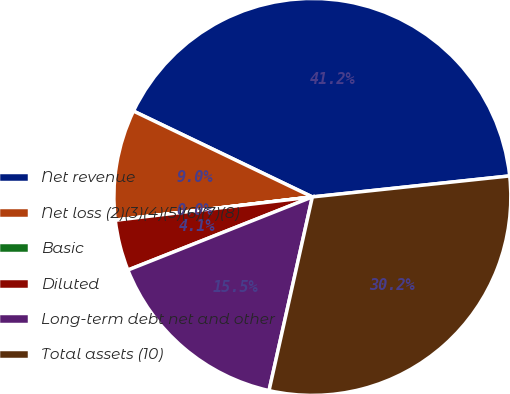Convert chart. <chart><loc_0><loc_0><loc_500><loc_500><pie_chart><fcel>Net revenue<fcel>Net loss (2)(3)(4)(5)(6)(7)(8)<fcel>Basic<fcel>Diluted<fcel>Long-term debt net and other<fcel>Total assets (10)<nl><fcel>41.19%<fcel>8.99%<fcel>0.01%<fcel>4.13%<fcel>15.49%<fcel>30.19%<nl></chart> 